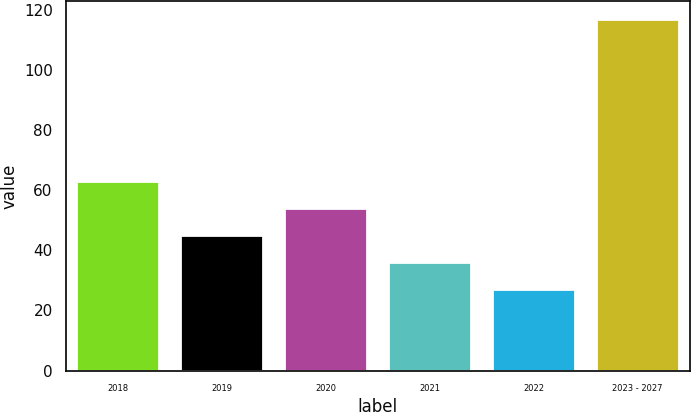<chart> <loc_0><loc_0><loc_500><loc_500><bar_chart><fcel>2018<fcel>2019<fcel>2020<fcel>2021<fcel>2022<fcel>2023 - 2027<nl><fcel>63<fcel>45<fcel>54<fcel>36<fcel>27<fcel>117<nl></chart> 